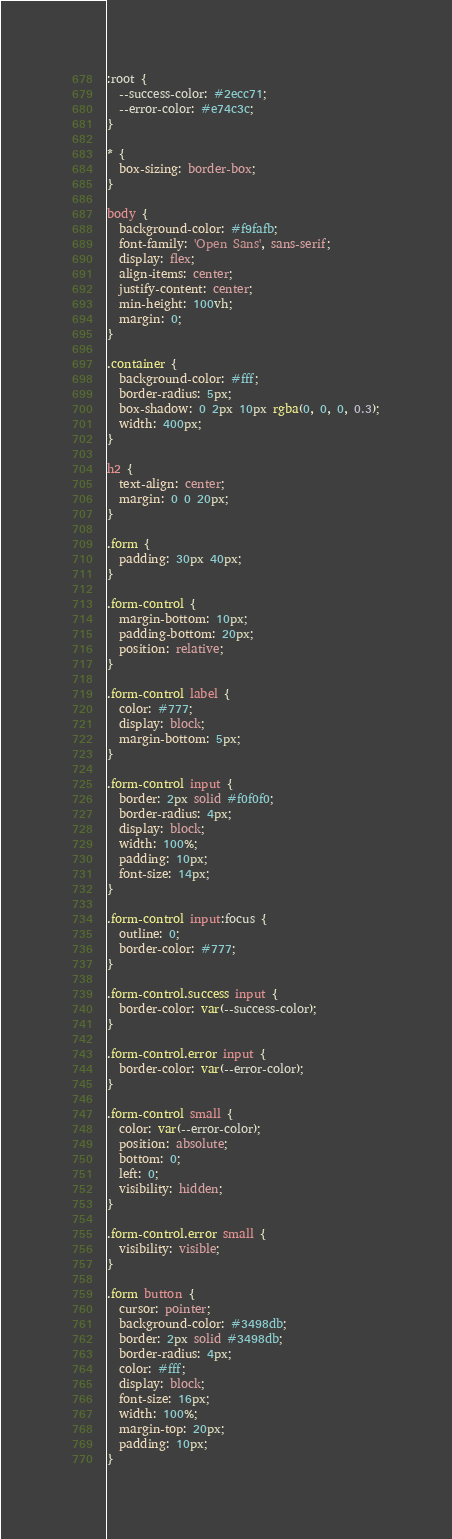Convert code to text. <code><loc_0><loc_0><loc_500><loc_500><_CSS_>:root {
  --success-color: #2ecc71;
  --error-color: #e74c3c;
}

* {
  box-sizing: border-box;
}

body {
  background-color: #f9fafb;
  font-family: 'Open Sans', sans-serif;
  display: flex;
  align-items: center;
  justify-content: center;
  min-height: 100vh;
  margin: 0;
}

.container {
  background-color: #fff;
  border-radius: 5px;
  box-shadow: 0 2px 10px rgba(0, 0, 0, 0.3);
  width: 400px;
}

h2 {
  text-align: center;
  margin: 0 0 20px;
}

.form {
  padding: 30px 40px;
}

.form-control {
  margin-bottom: 10px;
  padding-bottom: 20px;
  position: relative;
}

.form-control label {
  color: #777;
  display: block;
  margin-bottom: 5px;
}

.form-control input {
  border: 2px solid #f0f0f0;
  border-radius: 4px;
  display: block;
  width: 100%;
  padding: 10px;
  font-size: 14px;
}

.form-control input:focus {
  outline: 0;
  border-color: #777;
}

.form-control.success input {
  border-color: var(--success-color);
}

.form-control.error input {
  border-color: var(--error-color);
}

.form-control small {
  color: var(--error-color);
  position: absolute;
  bottom: 0;
  left: 0;
  visibility: hidden;
}

.form-control.error small {
  visibility: visible;
}

.form button {
  cursor: pointer;
  background-color: #3498db;
  border: 2px solid #3498db;
  border-radius: 4px;
  color: #fff;
  display: block;
  font-size: 16px;
  width: 100%;
  margin-top: 20px;
  padding: 10px;
}
</code> 